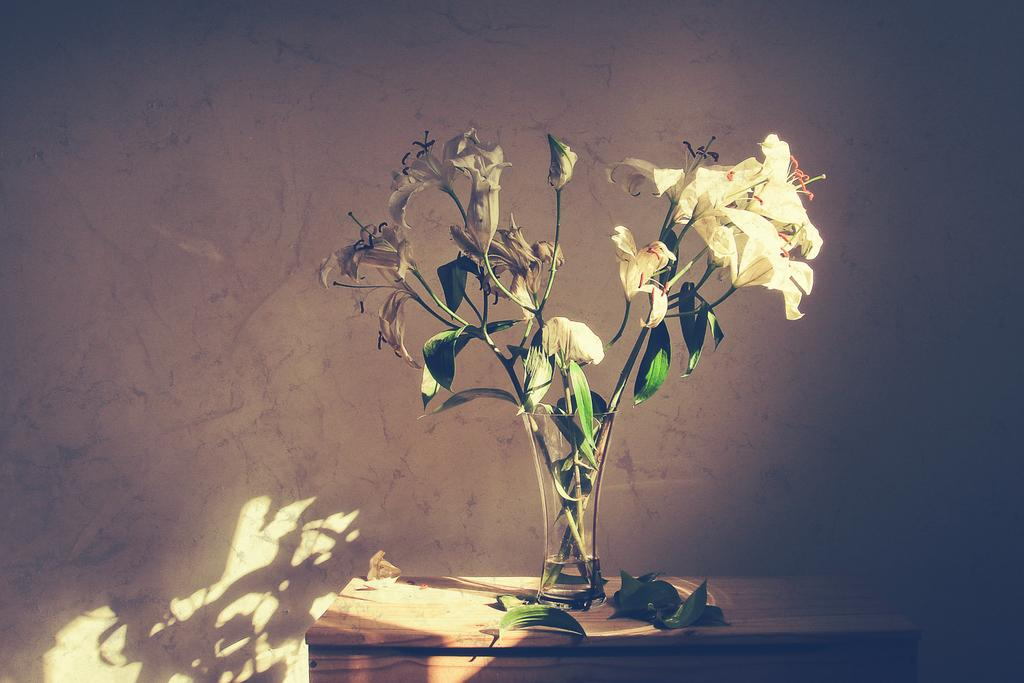What piece of furniture is present in the image? There is a table in the image. What is placed on the table? There is a flower vase on the table. What else can be seen on the table? There are leaves on the table. What can be seen in the background of the image? There is a wall in the background of the image. What type of crime is being committed in the image? There is no crime being committed in the image; it features a table with a flower vase and leaves. Can you tell me who is arguing with whom in the image? There is no argument present in the image; it features a table with a flower vase and leaves. 